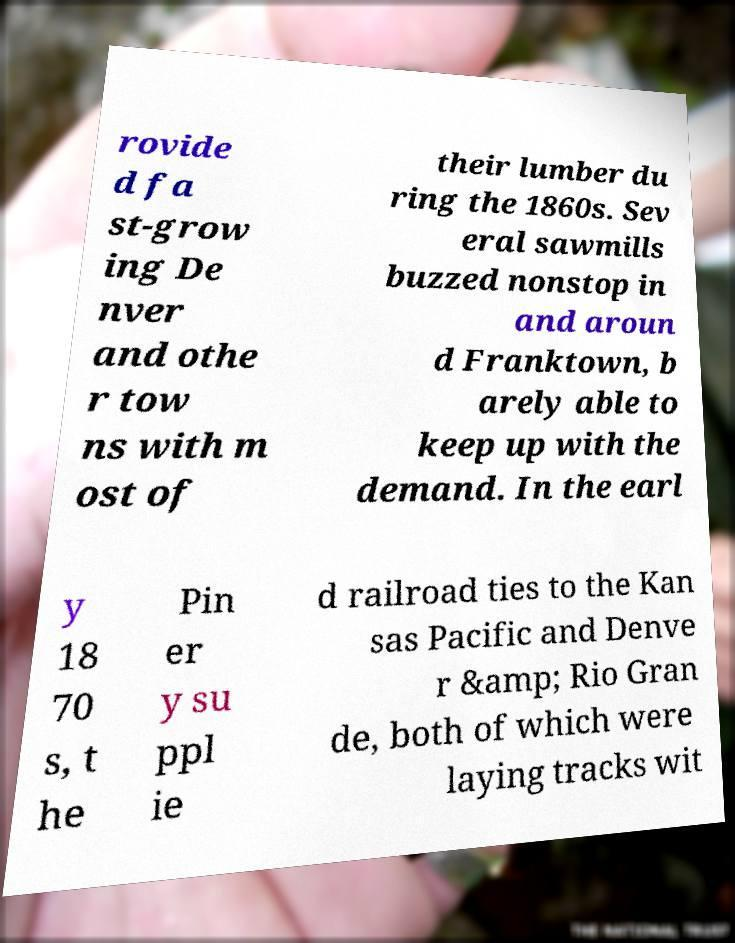Please identify and transcribe the text found in this image. rovide d fa st-grow ing De nver and othe r tow ns with m ost of their lumber du ring the 1860s. Sev eral sawmills buzzed nonstop in and aroun d Franktown, b arely able to keep up with the demand. In the earl y 18 70 s, t he Pin er y su ppl ie d railroad ties to the Kan sas Pacific and Denve r &amp; Rio Gran de, both of which were laying tracks wit 